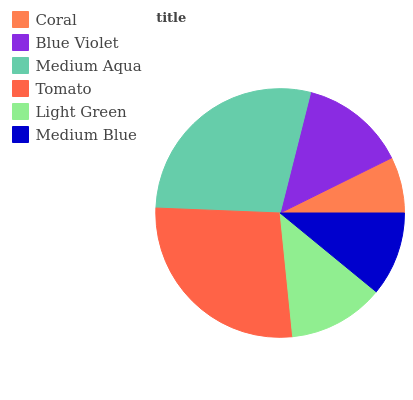Is Coral the minimum?
Answer yes or no. Yes. Is Medium Aqua the maximum?
Answer yes or no. Yes. Is Blue Violet the minimum?
Answer yes or no. No. Is Blue Violet the maximum?
Answer yes or no. No. Is Blue Violet greater than Coral?
Answer yes or no. Yes. Is Coral less than Blue Violet?
Answer yes or no. Yes. Is Coral greater than Blue Violet?
Answer yes or no. No. Is Blue Violet less than Coral?
Answer yes or no. No. Is Blue Violet the high median?
Answer yes or no. Yes. Is Light Green the low median?
Answer yes or no. Yes. Is Medium Aqua the high median?
Answer yes or no. No. Is Blue Violet the low median?
Answer yes or no. No. 